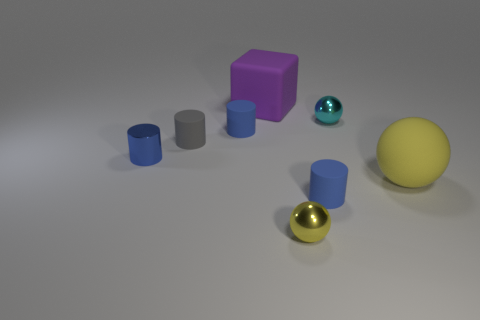Do the cube and the yellow rubber object have the same size?
Your response must be concise. Yes. There is a cyan object that is the same size as the gray rubber cylinder; what is its shape?
Offer a very short reply. Sphere. There is a shiny sphere in front of the blue metallic object; does it have the same size as the gray object?
Offer a terse response. Yes. There is a cyan thing that is the same size as the gray matte cylinder; what is it made of?
Offer a terse response. Metal. There is a ball that is in front of the small matte cylinder in front of the gray matte thing; is there a big thing that is on the left side of it?
Your answer should be compact. Yes. Is there any other thing that has the same shape as the big purple object?
Make the answer very short. No. Do the large object that is to the left of the small cyan object and the cylinder that is right of the tiny yellow metal object have the same color?
Provide a succinct answer. No. Are there any tiny purple matte blocks?
Ensure brevity in your answer.  No. There is another sphere that is the same color as the large sphere; what material is it?
Ensure brevity in your answer.  Metal. There is a sphere that is left of the matte cylinder that is to the right of the big object that is behind the small cyan ball; what size is it?
Keep it short and to the point. Small. 